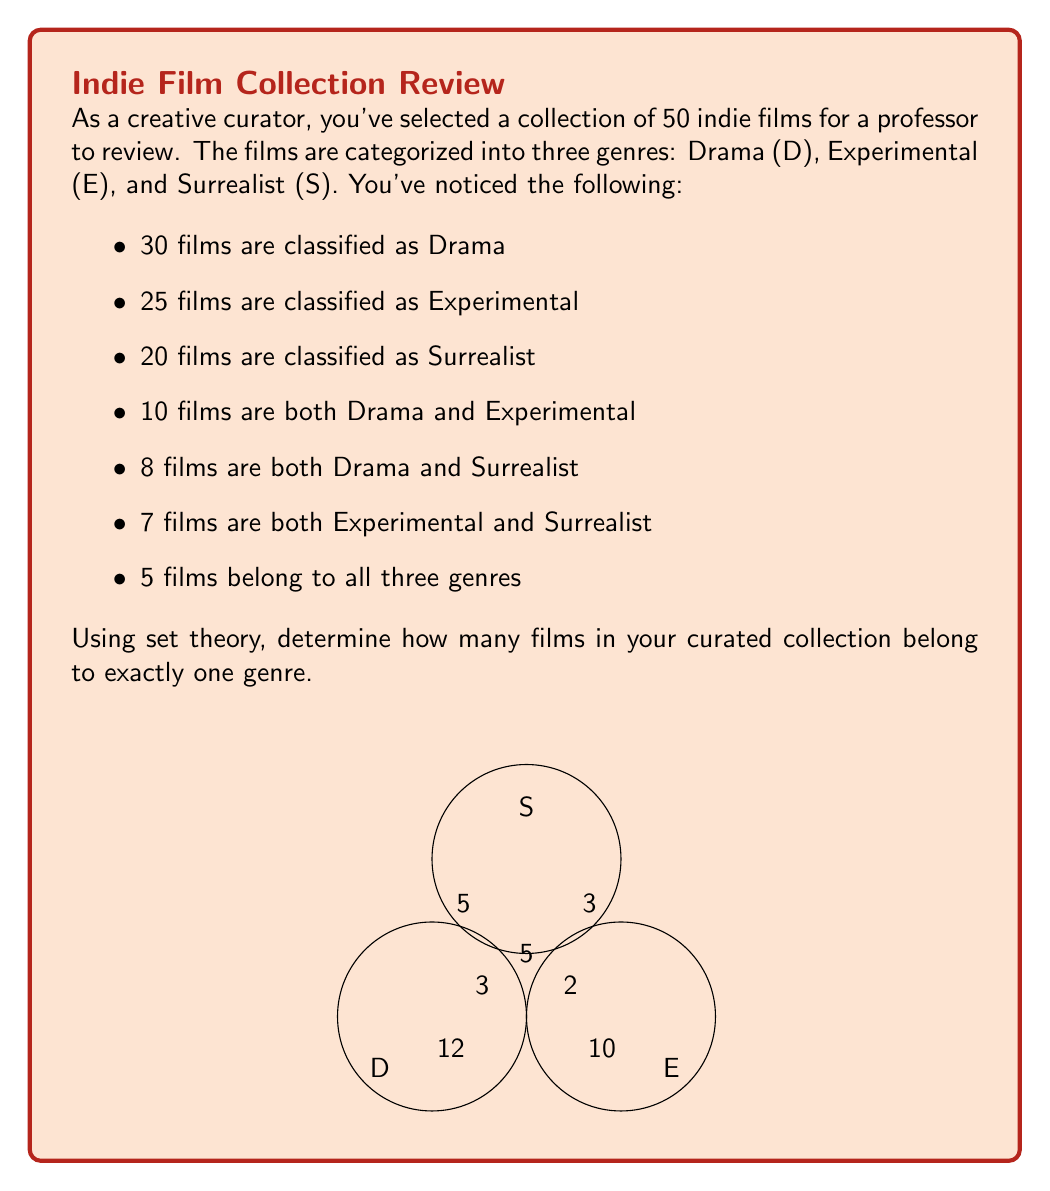Help me with this question. Let's approach this step-by-step using set theory:

1) Let's define our sets:
   D: Drama films
   E: Experimental films
   S: Surrealist films

2) We're given:
   $|D| = 30$, $|E| = 25$, $|S| = 20$
   $|D \cap E| = 10$, $|D \cap S| = 8$, $|E \cap S| = 7$
   $|D \cap E \cap S| = 5$

3) We need to find the number of films in exactly one genre. This is equivalent to:
   $|(D \setminus (E \cup S)) \cup (E \setminus (D \cup S)) \cup (S \setminus (D \cup E))|$

4) We can use the principle of inclusion-exclusion:
   $|D \cup E \cup S| = |D| + |E| + |S| - |D \cap E| - |D \cap S| - |E \cap S| + |D \cap E \cap S|$

5) Substituting the values:
   $|D \cup E \cup S| = 30 + 25 + 20 - 10 - 8 - 7 + 5 = 55$

6) The total number of films is 50, so there are 5 films that don't belong to any of these genres.

7) Now, to find films in exactly one genre, we subtract films in multiple genres and films in no genre from the total:
   $50 - (10 + 8 + 7 - 5) - 5 = 50 - 20 - 5 = 25$

Therefore, 25 films belong to exactly one genre.
Answer: 25 films 